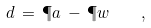Convert formula to latex. <formula><loc_0><loc_0><loc_500><loc_500>\L d \, = \, \P a \, - \, \P w \quad ,</formula> 